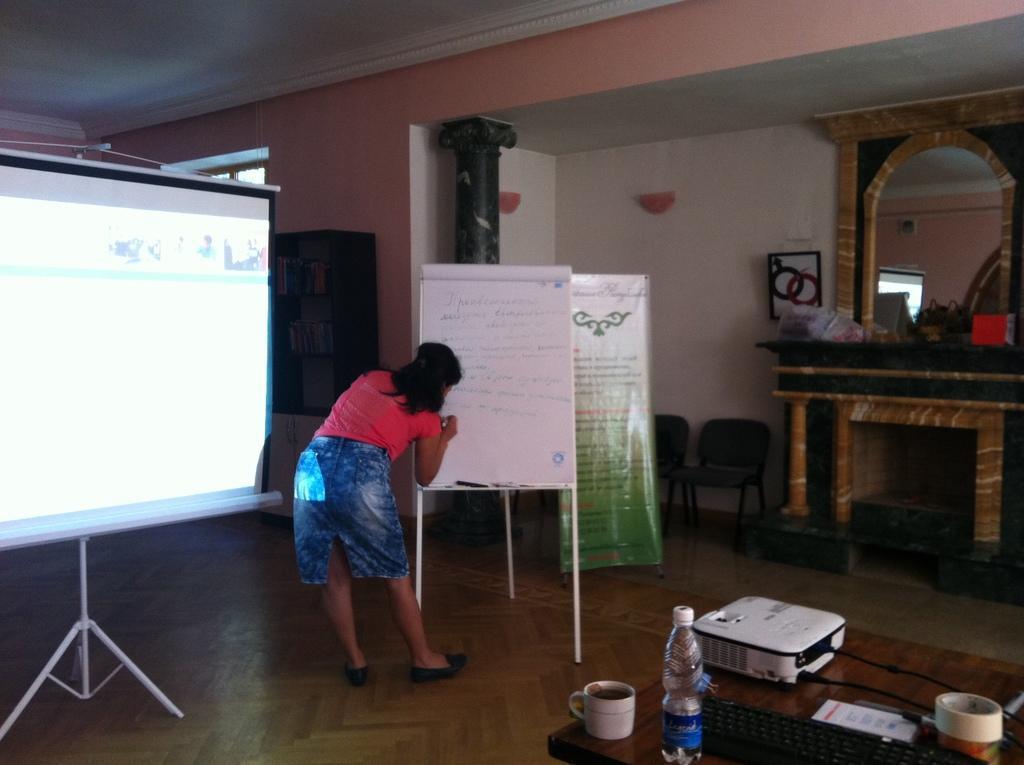In one or two sentences, can you explain what this image depicts? In this picture we can see a bottle, cup, keyboard, tape, device and a paper on a wooden table on the right side. There is a projector on the stand on the left side. We can see a woman writing on whiteboard. There are wooden objects and a frame on the wall. We can see a banner and chairs on the floor. There is a mirror and a few things are visible on the desk. 